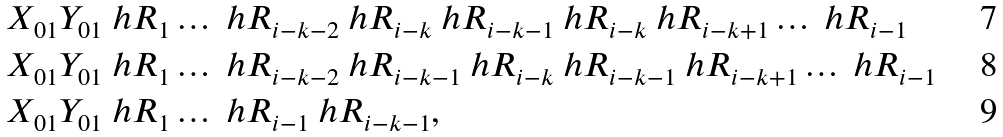<formula> <loc_0><loc_0><loc_500><loc_500>& X _ { 0 1 } Y _ { 0 1 } \ h R _ { 1 } \dots \ h R _ { i - k - 2 } \ h R _ { i - k } \ h R _ { i - k - 1 } \ h R _ { i - k } \ h R _ { i - k + 1 } \dots \ h R _ { i - 1 } \\ & X _ { 0 1 } Y _ { 0 1 } \ h R _ { 1 } \dots \ h R _ { i - k - 2 } \ h R _ { i - k - 1 } \ h R _ { i - k } \ h R _ { i - k - 1 } \ h R _ { i - k + 1 } \dots \ h R _ { i - 1 } \\ & X _ { 0 1 } Y _ { 0 1 } \ h R _ { 1 } \dots \ h R _ { i - 1 } \ h R _ { i - k - 1 } ,</formula> 